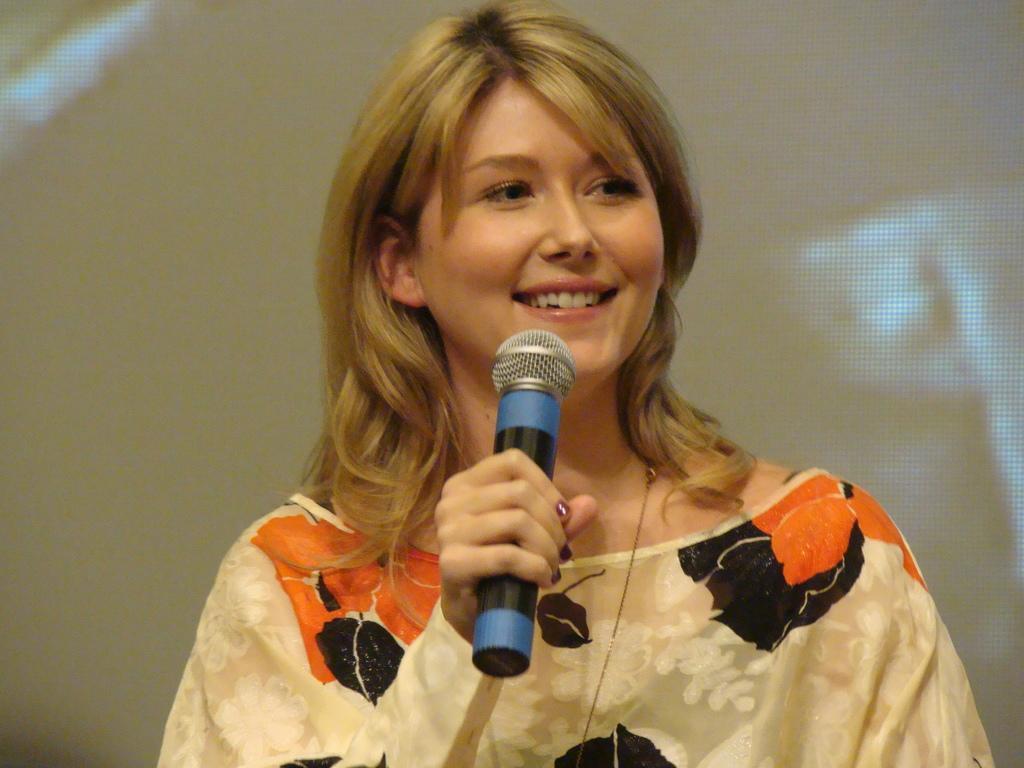How would you summarize this image in a sentence or two? In this picture we can find a woman smiling and holding a microphone, she is wearing a cream colored dress with orange colored flowers on it, and she is having a golden hair, in the background there is cream color. 